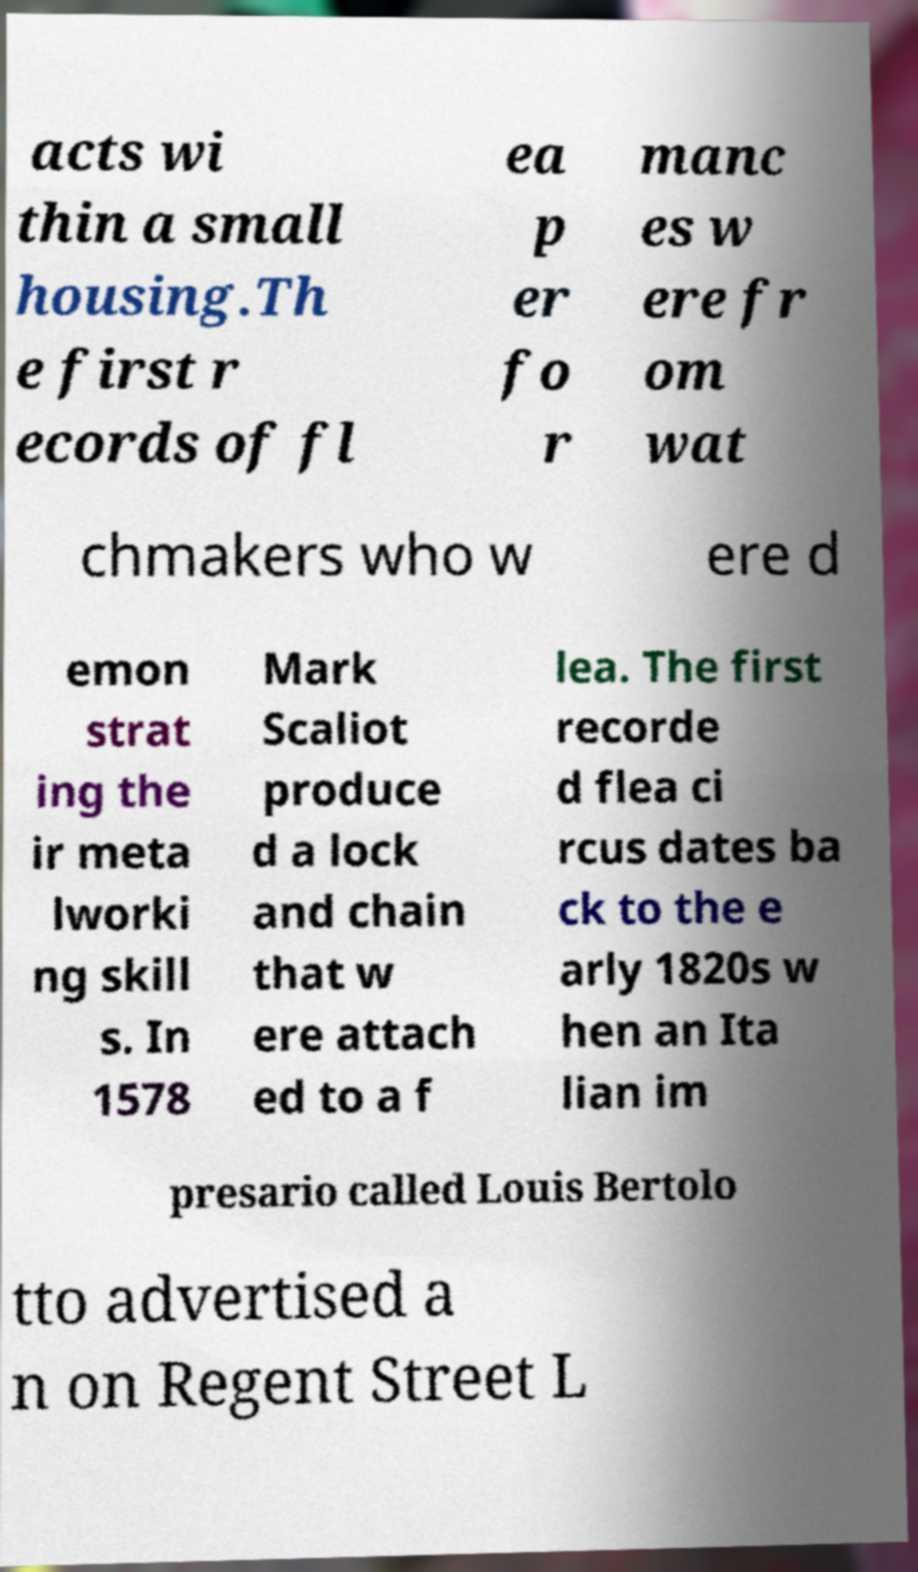Can you read and provide the text displayed in the image?This photo seems to have some interesting text. Can you extract and type it out for me? acts wi thin a small housing.Th e first r ecords of fl ea p er fo r manc es w ere fr om wat chmakers who w ere d emon strat ing the ir meta lworki ng skill s. In 1578 Mark Scaliot produce d a lock and chain that w ere attach ed to a f lea. The first recorde d flea ci rcus dates ba ck to the e arly 1820s w hen an Ita lian im presario called Louis Bertolo tto advertised a n on Regent Street L 